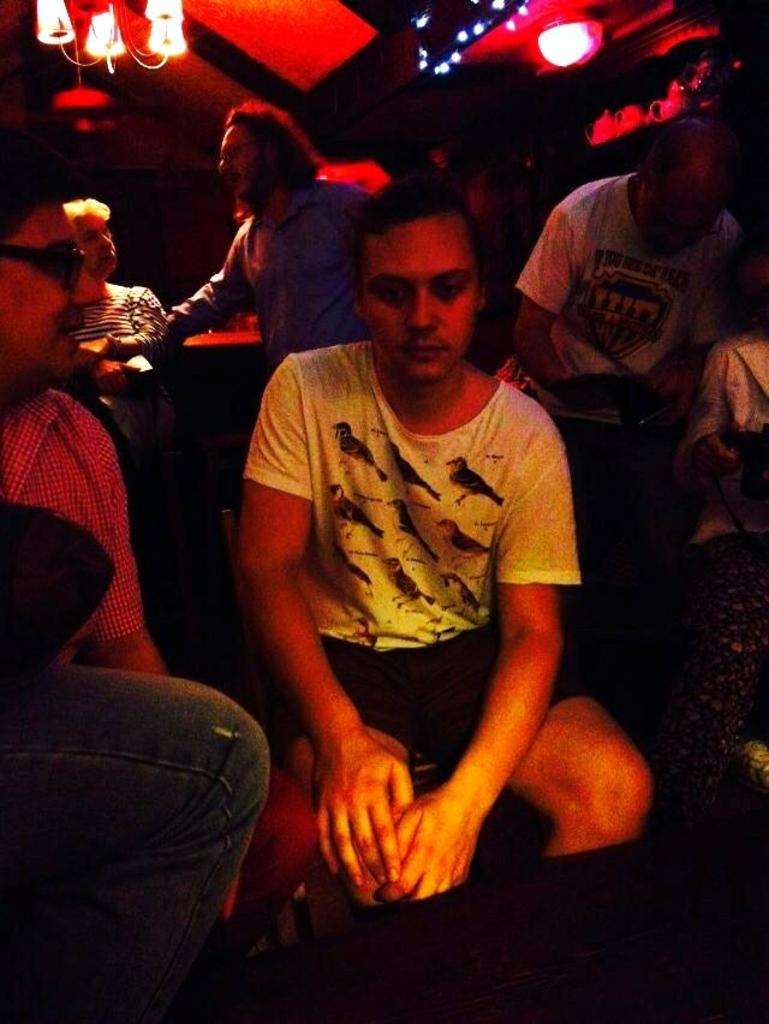Can you describe this image briefly? In the center of the image we can see person sitting. On the right and left side of the image we can see persons. In the background we can see persons, table and lights. 